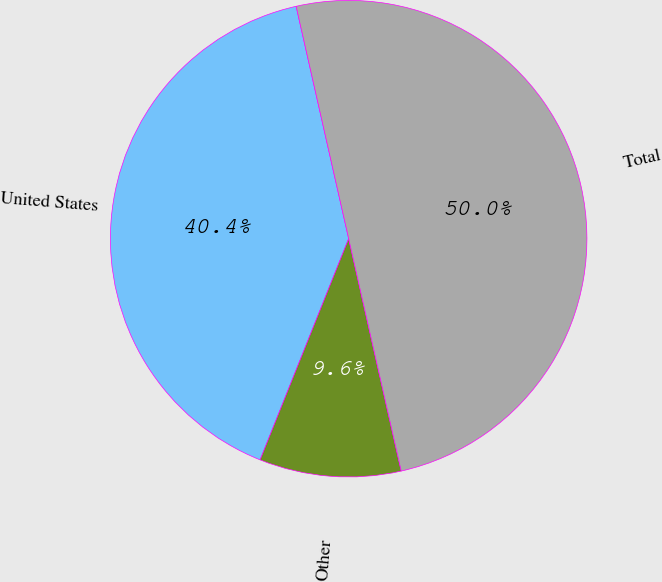Convert chart. <chart><loc_0><loc_0><loc_500><loc_500><pie_chart><fcel>United States<fcel>Other<fcel>Total<nl><fcel>40.4%<fcel>9.6%<fcel>50.0%<nl></chart> 